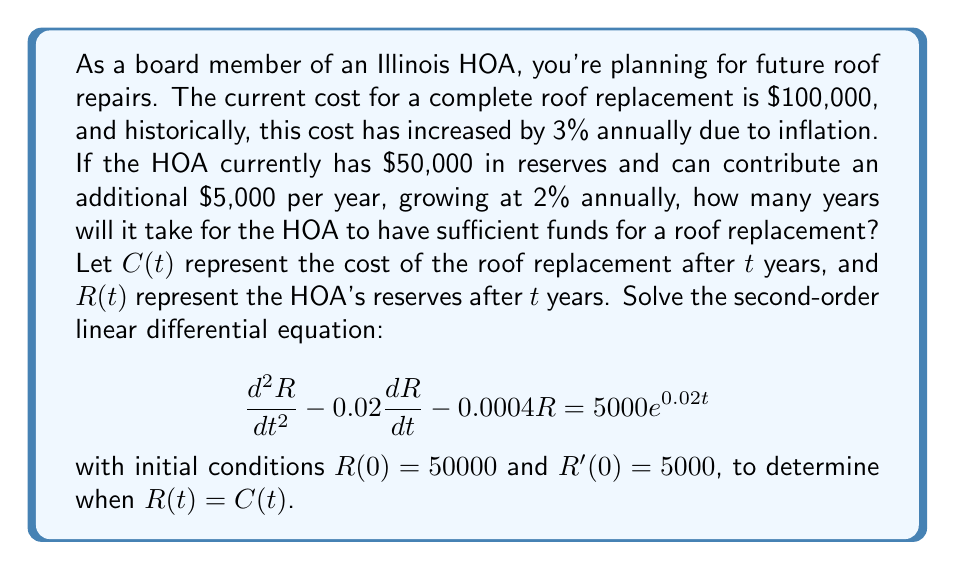Teach me how to tackle this problem. Let's approach this problem step by step:

1) First, we need to model the cost of the roof replacement:
   $C(t) = 100000 \cdot (1.03)^t$

2) For the reserves, we have the given differential equation:
   $$\frac{d^2R}{dt^2} - 0.02\frac{dR}{dt} - 0.0004R = 5000e^{0.02t}$$

3) The general solution to this equation is of the form:
   $R(t) = A_1e^{r_1t} + A_2e^{r_2t} + B_1e^{0.02t}$

4) To find $r_1$ and $r_2$, we solve the characteristic equation:
   $r^2 - 0.02r - 0.0004 = 0$
   $r = 0.0204$ or $r = -0.0004$

5) To find $B_1$, we substitute the particular solution into the original equation:
   $B_1 = \frac{5000}{0.0004} = 12500000$

6) Now our general solution is:
   $R(t) = A_1e^{0.0204t} + A_2e^{-0.0004t} + 12500000e^{0.02t}$

7) Using the initial conditions:
   $R(0) = 50000 = A_1 + A_2 + 12500000$
   $R'(0) = 5000 = 0.0204A_1 - 0.0004A_2 + 250000$

8) Solving this system of equations:
   $A_1 \approx -12449553.19$
   $A_2 \approx -446.81$

9) Our final solution for $R(t)$ is:
   $R(t) = -12449553.19e^{0.0204t} - 446.81e^{-0.0004t} + 12500000e^{0.02t}$

10) To find when $R(t) = C(t)$, we need to solve:
    $-12449553.19e^{0.0204t} - 446.81e^{-0.0004t} + 12500000e^{0.02t} = 100000 \cdot (1.03)^t$

11) This equation can be solved numerically, giving us:
    $t \approx 18.76$ years
Answer: It will take approximately 18.76 years for the HOA to have sufficient funds for a roof replacement. 